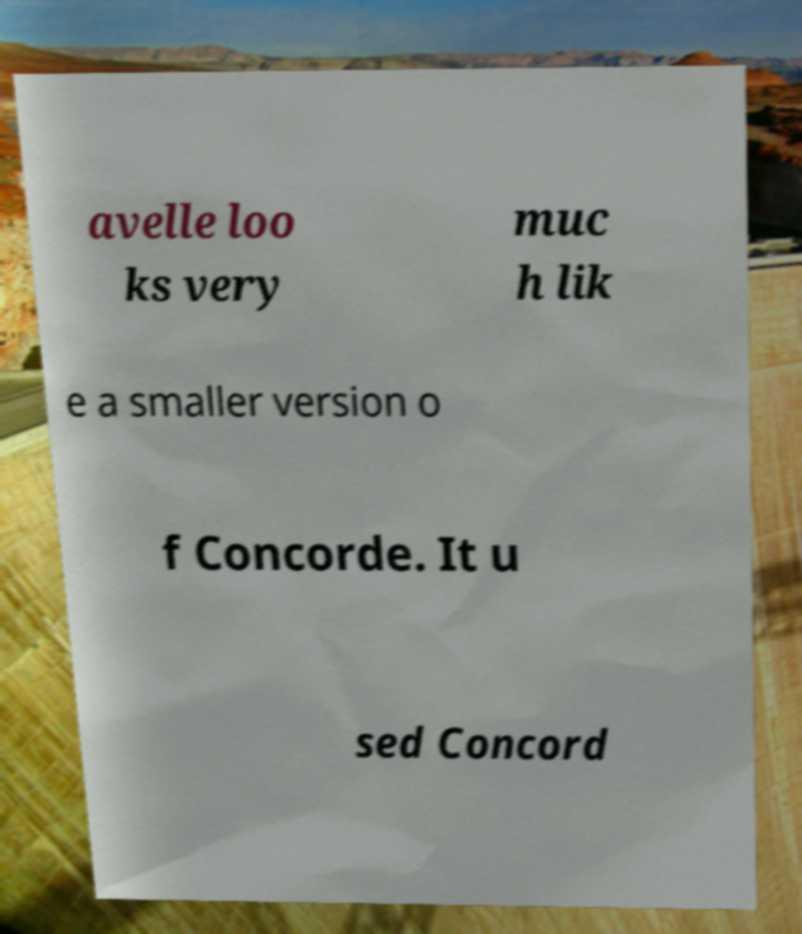What messages or text are displayed in this image? I need them in a readable, typed format. avelle loo ks very muc h lik e a smaller version o f Concorde. It u sed Concord 